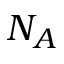<formula> <loc_0><loc_0><loc_500><loc_500>N _ { A }</formula> 